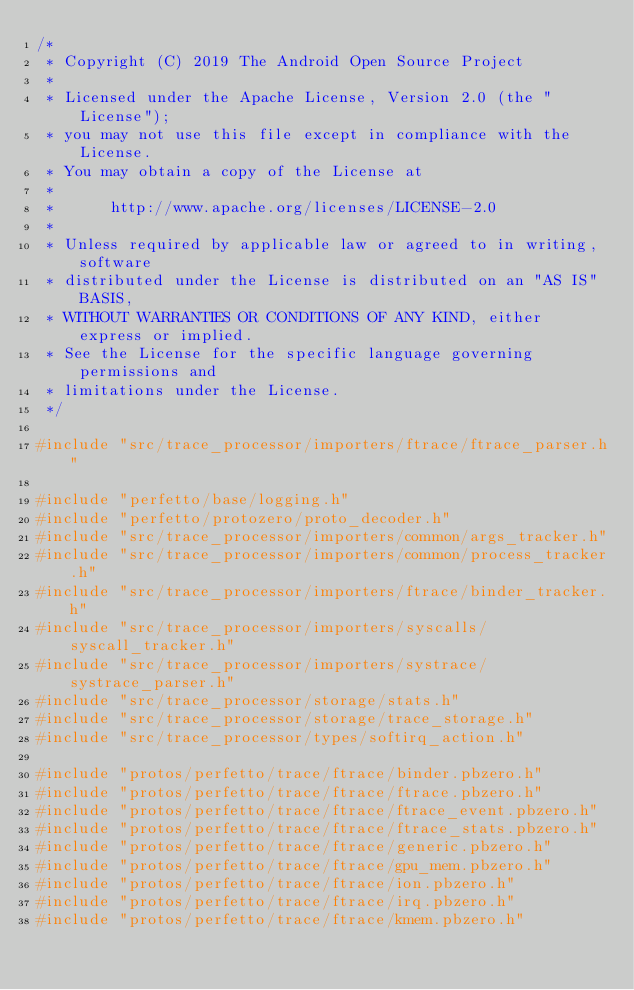Convert code to text. <code><loc_0><loc_0><loc_500><loc_500><_C++_>/*
 * Copyright (C) 2019 The Android Open Source Project
 *
 * Licensed under the Apache License, Version 2.0 (the "License");
 * you may not use this file except in compliance with the License.
 * You may obtain a copy of the License at
 *
 *      http://www.apache.org/licenses/LICENSE-2.0
 *
 * Unless required by applicable law or agreed to in writing, software
 * distributed under the License is distributed on an "AS IS" BASIS,
 * WITHOUT WARRANTIES OR CONDITIONS OF ANY KIND, either express or implied.
 * See the License for the specific language governing permissions and
 * limitations under the License.
 */

#include "src/trace_processor/importers/ftrace/ftrace_parser.h"

#include "perfetto/base/logging.h"
#include "perfetto/protozero/proto_decoder.h"
#include "src/trace_processor/importers/common/args_tracker.h"
#include "src/trace_processor/importers/common/process_tracker.h"
#include "src/trace_processor/importers/ftrace/binder_tracker.h"
#include "src/trace_processor/importers/syscalls/syscall_tracker.h"
#include "src/trace_processor/importers/systrace/systrace_parser.h"
#include "src/trace_processor/storage/stats.h"
#include "src/trace_processor/storage/trace_storage.h"
#include "src/trace_processor/types/softirq_action.h"

#include "protos/perfetto/trace/ftrace/binder.pbzero.h"
#include "protos/perfetto/trace/ftrace/ftrace.pbzero.h"
#include "protos/perfetto/trace/ftrace/ftrace_event.pbzero.h"
#include "protos/perfetto/trace/ftrace/ftrace_stats.pbzero.h"
#include "protos/perfetto/trace/ftrace/generic.pbzero.h"
#include "protos/perfetto/trace/ftrace/gpu_mem.pbzero.h"
#include "protos/perfetto/trace/ftrace/ion.pbzero.h"
#include "protos/perfetto/trace/ftrace/irq.pbzero.h"
#include "protos/perfetto/trace/ftrace/kmem.pbzero.h"</code> 